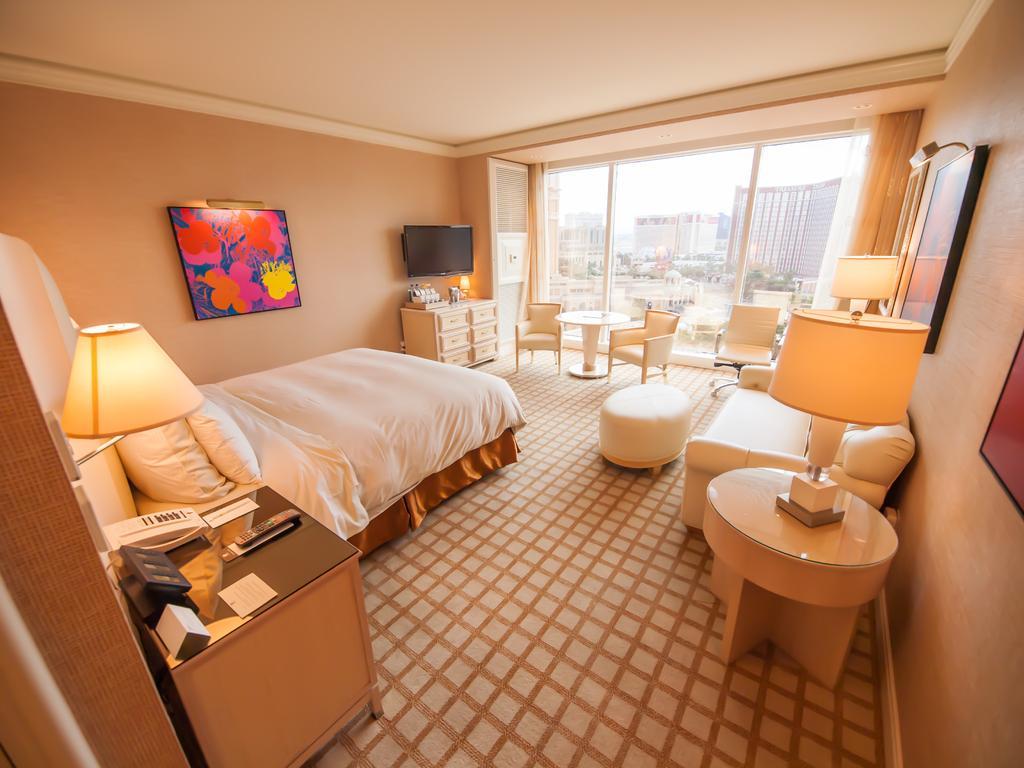Please provide a concise description of this image. In the image on the left side there is a lamp on the wall. In front of the wall there is a bed with pillows. Beside the bed there is a table with telephone, remote and some other things. On the right side of the image on the wall there are frames. In front of the wall there is a table with a lamp and sofa. In the background there are chairs, tables, walls with television and a frame. Behind the chairs there are glass walls with curtains. Behind the glass walls there are buildings. 